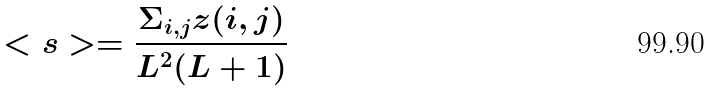<formula> <loc_0><loc_0><loc_500><loc_500>< s > = \frac { \Sigma _ { i , j } z ( i , j ) } { L ^ { 2 } ( L + 1 ) }</formula> 